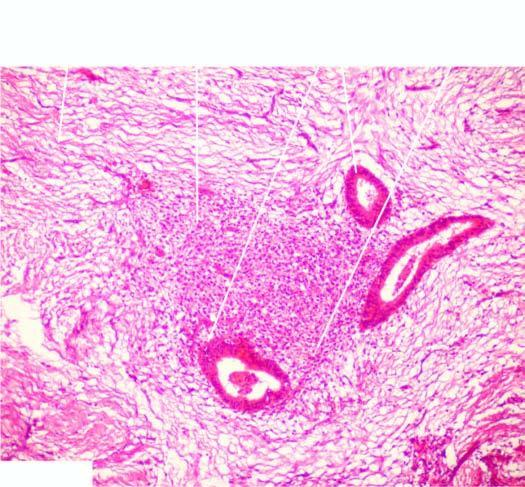what does dense fibrocollagenic tissue contain?
Answer the question using a single word or phrase. Endometrial glands 